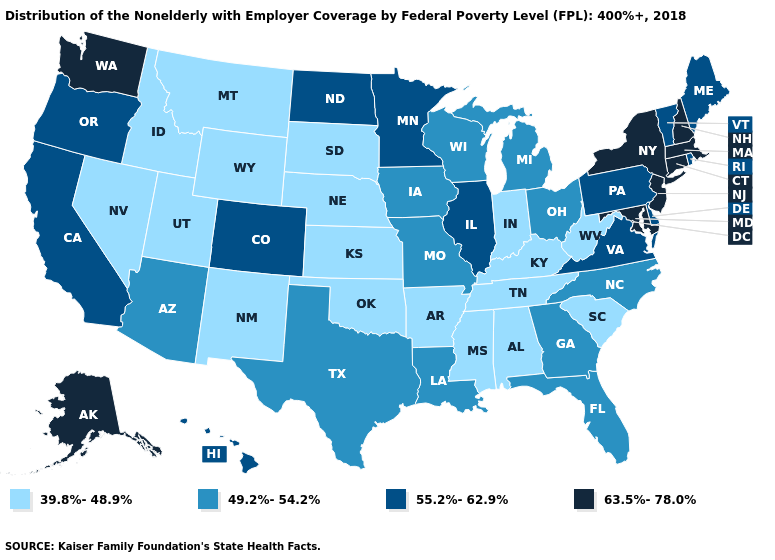Name the states that have a value in the range 63.5%-78.0%?
Quick response, please. Alaska, Connecticut, Maryland, Massachusetts, New Hampshire, New Jersey, New York, Washington. Name the states that have a value in the range 55.2%-62.9%?
Concise answer only. California, Colorado, Delaware, Hawaii, Illinois, Maine, Minnesota, North Dakota, Oregon, Pennsylvania, Rhode Island, Vermont, Virginia. Which states have the lowest value in the MidWest?
Short answer required. Indiana, Kansas, Nebraska, South Dakota. Name the states that have a value in the range 39.8%-48.9%?
Concise answer only. Alabama, Arkansas, Idaho, Indiana, Kansas, Kentucky, Mississippi, Montana, Nebraska, Nevada, New Mexico, Oklahoma, South Carolina, South Dakota, Tennessee, Utah, West Virginia, Wyoming. Which states hav the highest value in the Northeast?
Quick response, please. Connecticut, Massachusetts, New Hampshire, New Jersey, New York. What is the value of Alabama?
Be succinct. 39.8%-48.9%. Does the first symbol in the legend represent the smallest category?
Short answer required. Yes. What is the value of Rhode Island?
Write a very short answer. 55.2%-62.9%. What is the value of Texas?
Be succinct. 49.2%-54.2%. Among the states that border Idaho , does Washington have the highest value?
Concise answer only. Yes. What is the highest value in states that border California?
Be succinct. 55.2%-62.9%. Name the states that have a value in the range 55.2%-62.9%?
Be succinct. California, Colorado, Delaware, Hawaii, Illinois, Maine, Minnesota, North Dakota, Oregon, Pennsylvania, Rhode Island, Vermont, Virginia. Name the states that have a value in the range 49.2%-54.2%?
Answer briefly. Arizona, Florida, Georgia, Iowa, Louisiana, Michigan, Missouri, North Carolina, Ohio, Texas, Wisconsin. Name the states that have a value in the range 39.8%-48.9%?
Keep it brief. Alabama, Arkansas, Idaho, Indiana, Kansas, Kentucky, Mississippi, Montana, Nebraska, Nevada, New Mexico, Oklahoma, South Carolina, South Dakota, Tennessee, Utah, West Virginia, Wyoming. How many symbols are there in the legend?
Quick response, please. 4. 